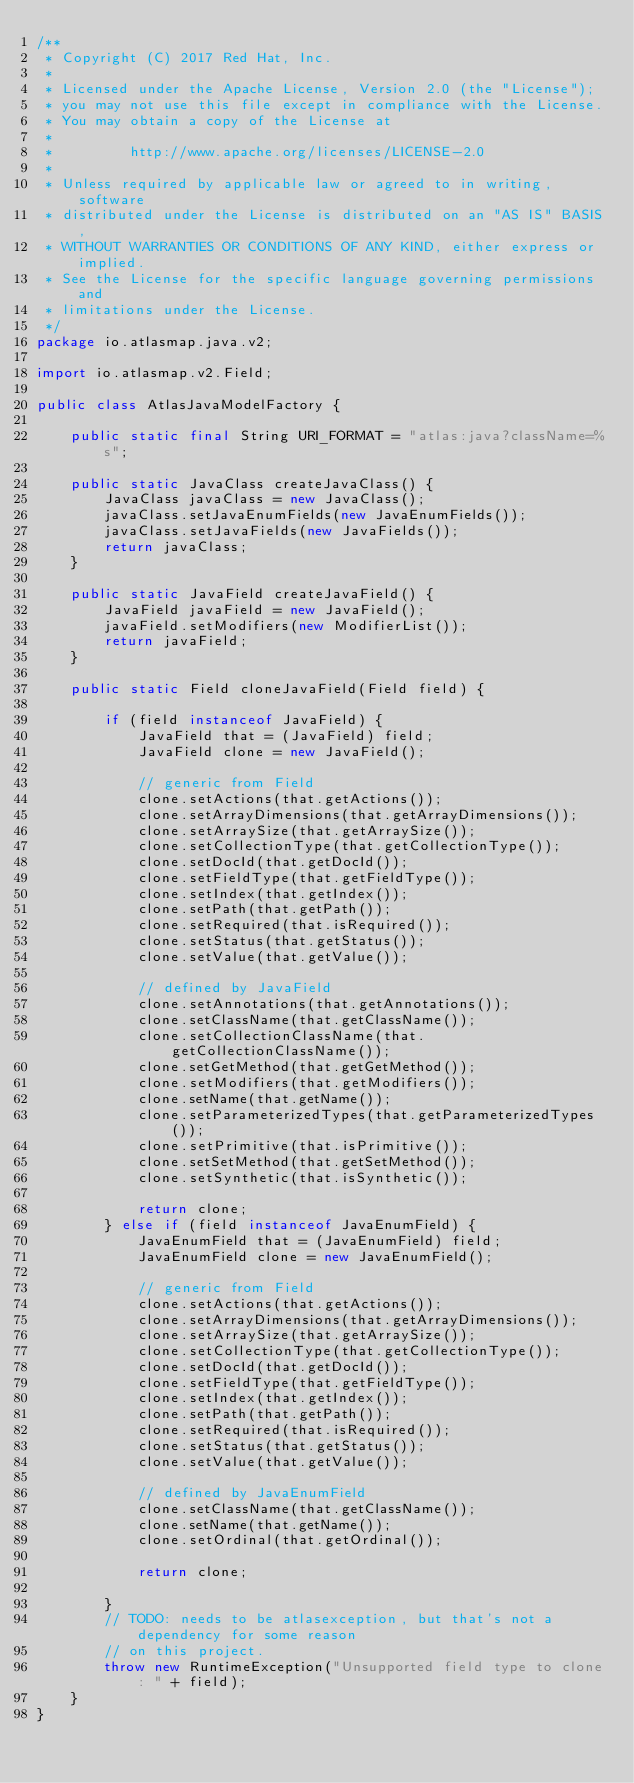Convert code to text. <code><loc_0><loc_0><loc_500><loc_500><_Java_>/**
 * Copyright (C) 2017 Red Hat, Inc.
 *
 * Licensed under the Apache License, Version 2.0 (the "License");
 * you may not use this file except in compliance with the License.
 * You may obtain a copy of the License at
 *
 *         http://www.apache.org/licenses/LICENSE-2.0
 *
 * Unless required by applicable law or agreed to in writing, software
 * distributed under the License is distributed on an "AS IS" BASIS,
 * WITHOUT WARRANTIES OR CONDITIONS OF ANY KIND, either express or implied.
 * See the License for the specific language governing permissions and
 * limitations under the License.
 */
package io.atlasmap.java.v2;

import io.atlasmap.v2.Field;

public class AtlasJavaModelFactory {

    public static final String URI_FORMAT = "atlas:java?className=%s";

    public static JavaClass createJavaClass() {
        JavaClass javaClass = new JavaClass();
        javaClass.setJavaEnumFields(new JavaEnumFields());
        javaClass.setJavaFields(new JavaFields());
        return javaClass;
    }

    public static JavaField createJavaField() {
        JavaField javaField = new JavaField();
        javaField.setModifiers(new ModifierList());
        return javaField;
    }

    public static Field cloneJavaField(Field field) {

        if (field instanceof JavaField) {
            JavaField that = (JavaField) field;
            JavaField clone = new JavaField();

            // generic from Field
            clone.setActions(that.getActions());
            clone.setArrayDimensions(that.getArrayDimensions());
            clone.setArraySize(that.getArraySize());
            clone.setCollectionType(that.getCollectionType());
            clone.setDocId(that.getDocId());
            clone.setFieldType(that.getFieldType());
            clone.setIndex(that.getIndex());
            clone.setPath(that.getPath());
            clone.setRequired(that.isRequired());
            clone.setStatus(that.getStatus());
            clone.setValue(that.getValue());

            // defined by JavaField
            clone.setAnnotations(that.getAnnotations());
            clone.setClassName(that.getClassName());
            clone.setCollectionClassName(that.getCollectionClassName());
            clone.setGetMethod(that.getGetMethod());
            clone.setModifiers(that.getModifiers());
            clone.setName(that.getName());
            clone.setParameterizedTypes(that.getParameterizedTypes());
            clone.setPrimitive(that.isPrimitive());
            clone.setSetMethod(that.getSetMethod());
            clone.setSynthetic(that.isSynthetic());

            return clone;
        } else if (field instanceof JavaEnumField) {
            JavaEnumField that = (JavaEnumField) field;
            JavaEnumField clone = new JavaEnumField();

            // generic from Field
            clone.setActions(that.getActions());
            clone.setArrayDimensions(that.getArrayDimensions());
            clone.setArraySize(that.getArraySize());
            clone.setCollectionType(that.getCollectionType());
            clone.setDocId(that.getDocId());
            clone.setFieldType(that.getFieldType());
            clone.setIndex(that.getIndex());
            clone.setPath(that.getPath());
            clone.setRequired(that.isRequired());
            clone.setStatus(that.getStatus());
            clone.setValue(that.getValue());

            // defined by JavaEnumField
            clone.setClassName(that.getClassName());
            clone.setName(that.getName());
            clone.setOrdinal(that.getOrdinal());

            return clone;

        }
        // TODO: needs to be atlasexception, but that's not a dependency for some reason
        // on this project.
        throw new RuntimeException("Unsupported field type to clone: " + field);
    }
}
</code> 